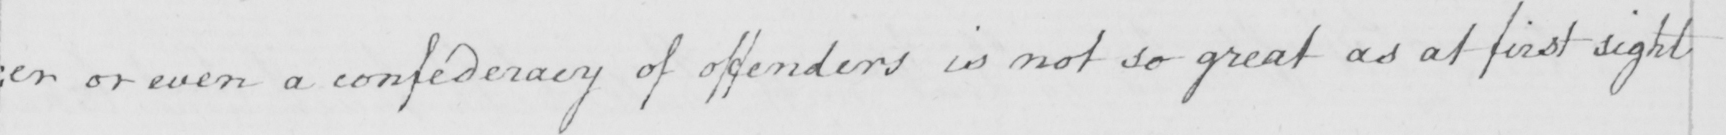What does this handwritten line say? : er or even a confederacy of offenders is not so great as at first sight 